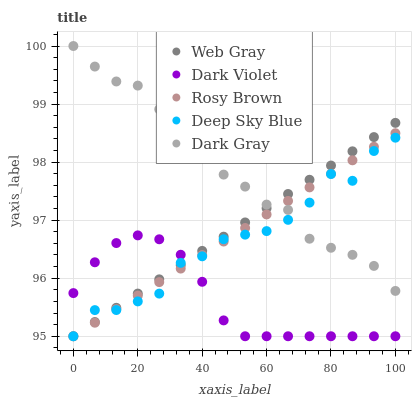Does Dark Violet have the minimum area under the curve?
Answer yes or no. Yes. Does Dark Gray have the maximum area under the curve?
Answer yes or no. Yes. Does Rosy Brown have the minimum area under the curve?
Answer yes or no. No. Does Rosy Brown have the maximum area under the curve?
Answer yes or no. No. Is Web Gray the smoothest?
Answer yes or no. Yes. Is Deep Sky Blue the roughest?
Answer yes or no. Yes. Is Rosy Brown the smoothest?
Answer yes or no. No. Is Rosy Brown the roughest?
Answer yes or no. No. Does Rosy Brown have the lowest value?
Answer yes or no. Yes. Does Dark Gray have the highest value?
Answer yes or no. Yes. Does Rosy Brown have the highest value?
Answer yes or no. No. Is Dark Violet less than Dark Gray?
Answer yes or no. Yes. Is Dark Gray greater than Dark Violet?
Answer yes or no. Yes. Does Rosy Brown intersect Deep Sky Blue?
Answer yes or no. Yes. Is Rosy Brown less than Deep Sky Blue?
Answer yes or no. No. Is Rosy Brown greater than Deep Sky Blue?
Answer yes or no. No. Does Dark Violet intersect Dark Gray?
Answer yes or no. No. 